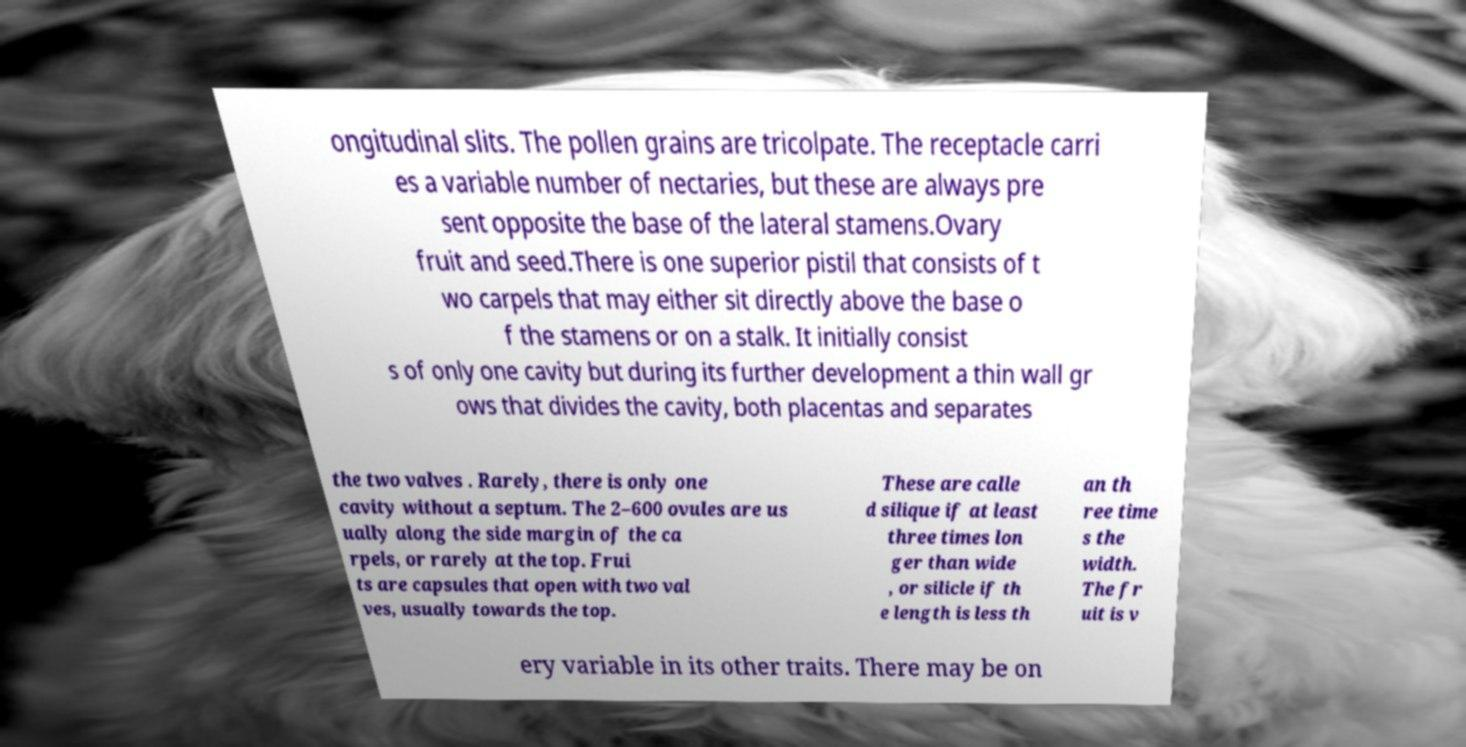Please identify and transcribe the text found in this image. ongitudinal slits. The pollen grains are tricolpate. The receptacle carri es a variable number of nectaries, but these are always pre sent opposite the base of the lateral stamens.Ovary fruit and seed.There is one superior pistil that consists of t wo carpels that may either sit directly above the base o f the stamens or on a stalk. It initially consist s of only one cavity but during its further development a thin wall gr ows that divides the cavity, both placentas and separates the two valves . Rarely, there is only one cavity without a septum. The 2–600 ovules are us ually along the side margin of the ca rpels, or rarely at the top. Frui ts are capsules that open with two val ves, usually towards the top. These are calle d silique if at least three times lon ger than wide , or silicle if th e length is less th an th ree time s the width. The fr uit is v ery variable in its other traits. There may be on 